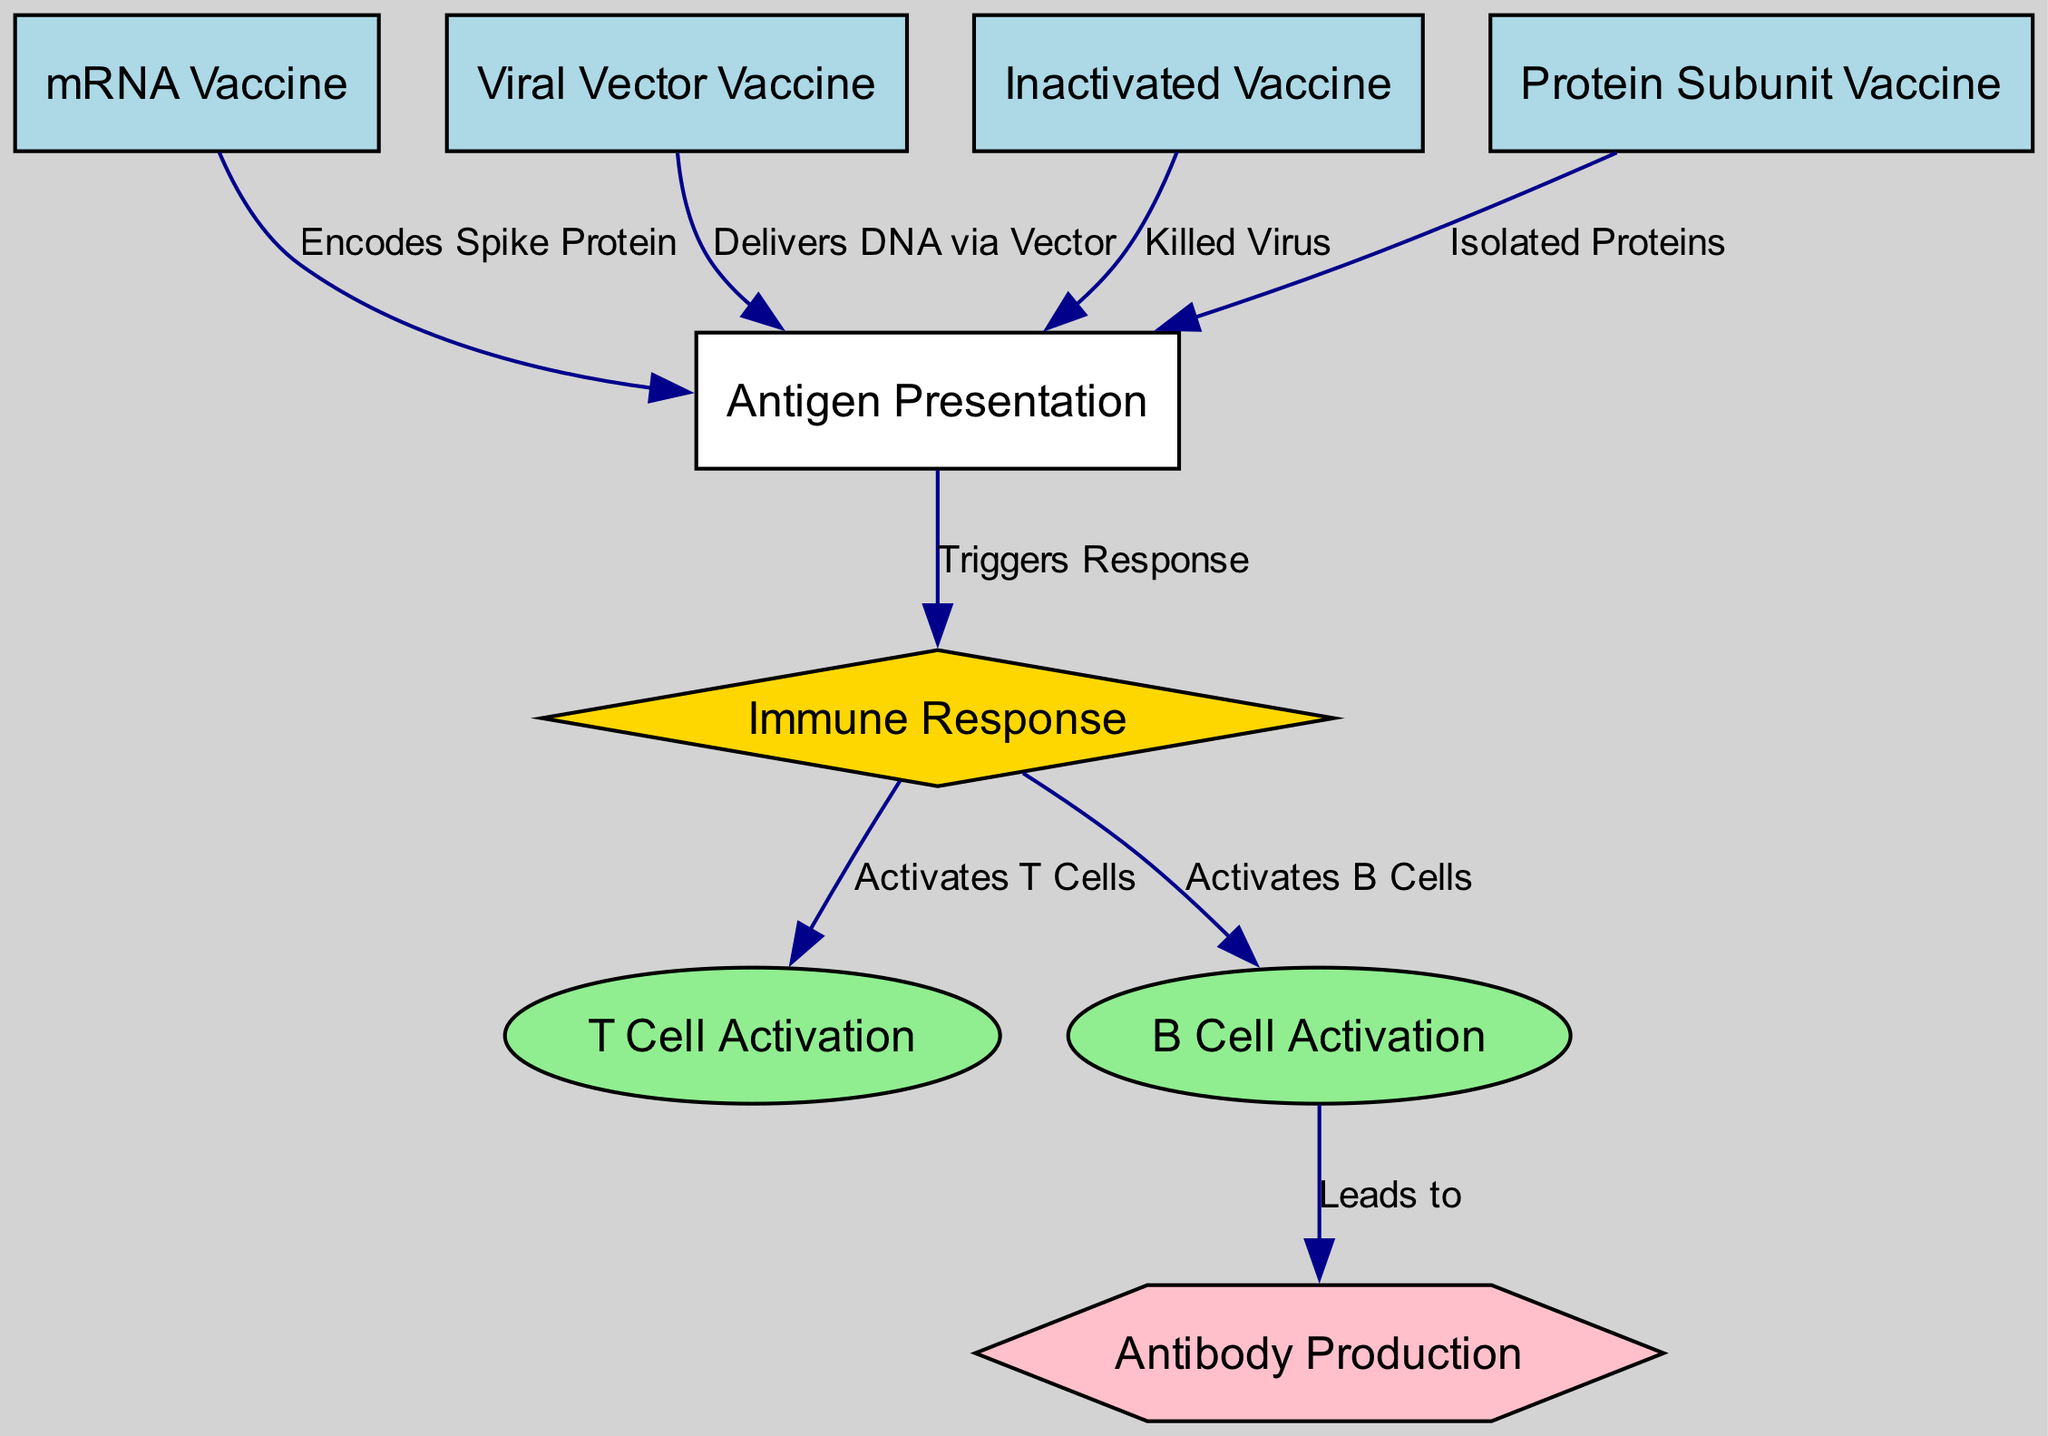What is the total number of nodes in the diagram? The diagram has nodes that represent different vaccines and immune system responses. Counting the nodes listed, we find eight nodes in total: mRNA Vaccine, Viral Vector Vaccine, Inactivated Vaccine, Protein Subunit Vaccine, Immune Response, Antigen Presentation, T Cell Activation, B Cell Activation, and Antibody Production.
Answer: 8 What type of vaccine uses the method "Isolated Proteins"? In the diagram, the node corresponding to "Isolated Proteins" is connected to the Protein Subunit Vaccine, which indicates that this type of vaccine utilizes the isolated proteins to trigger an immune response.
Answer: Protein Subunit Vaccine How do mRNA vaccines trigger antibody production? The process starts with the mRNA vaccine leading to antigen presentation, which then triggers an immune response. This immune response activates B cells, which ultimately leads to antibody production as represented in the flow of the diagram.
Answer: Through B Cell Activation What does the Viral Vector Vaccine deliver to elicit an immune response? According to the edge connecting the Viral Vector Vaccine to the Antigen Presentation node, it delivers DNA via a vector to stimulate the immune system.
Answer: DNA via Vector Which immune activation follows B Cell Activation in the diagram? After the B Cell Activation node in the diagram, the connection towards the Antibody Production node indicates that the next process following B Cell Activation is the production of antibodies.
Answer: Antibody Production What are the two types of activation triggered by the Immune Response? The Immune Response node shows two outgoing edges: one leads to T Cell Activation and the other to B Cell Activation. This indicates that the Immune Response activates both types of cells.
Answer: T Cell Activation and B Cell Activation 